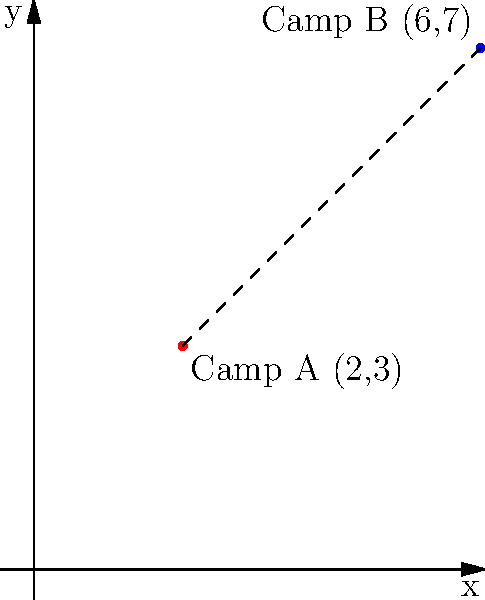During the Civil War, two Union army camps are located on a coordinate plane. Camp A is situated at (2,3) and Camp B at (6,7). Using the distance formula, calculate the straight-line distance between these two camps. Round your answer to two decimal places. To solve this problem, we'll use the distance formula derived from the Pythagorean theorem:

$$d = \sqrt{(x_2 - x_1)^2 + (y_2 - y_1)^2}$$

Where $(x_1, y_1)$ are the coordinates of the first point and $(x_2, y_2)$ are the coordinates of the second point.

Step 1: Identify the coordinates
Camp A: $(x_1, y_1) = (2, 3)$
Camp B: $(x_2, y_2) = (6, 7)$

Step 2: Plug the coordinates into the distance formula
$$d = \sqrt{(6 - 2)^2 + (7 - 3)^2}$$

Step 3: Simplify the expressions inside the parentheses
$$d = \sqrt{4^2 + 4^2}$$

Step 4: Calculate the squares
$$d = \sqrt{16 + 16}$$

Step 5: Add the values under the square root
$$d = \sqrt{32}$$

Step 6: Simplify the square root
$$d = 4\sqrt{2} \approx 5.66$$

Step 7: Round to two decimal places
$$d \approx 5.66$$

Therefore, the distance between the two camps is approximately 5.66 units.
Answer: 5.66 units 